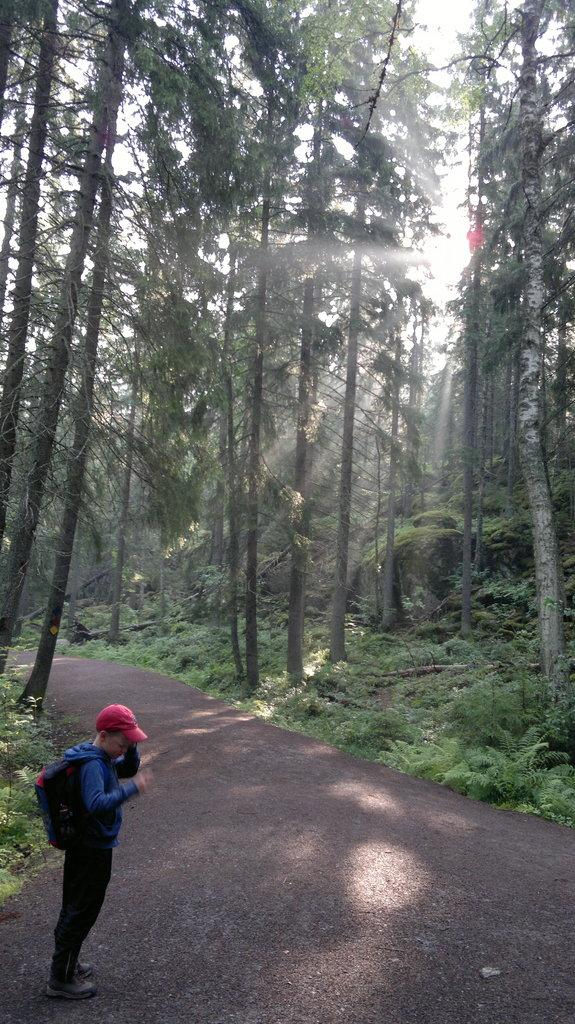What is the main subject of the image? There is a person standing in the image. What is the person holding or carrying? The person is carrying a bag. What can be seen in the background of the image? There is a group of trees and plants visible in the background. What is visible at the top of the image? The sky is visible at the top of the image. What is the weather like in the image? Sunshine is present in the image, suggesting a clear day. How many chairs are visible in the image? There are no chairs present in the image. What type of cherry is growing on the trees in the background? There are no cherries mentioned or visible in the image; only trees and plants are present in the background. 